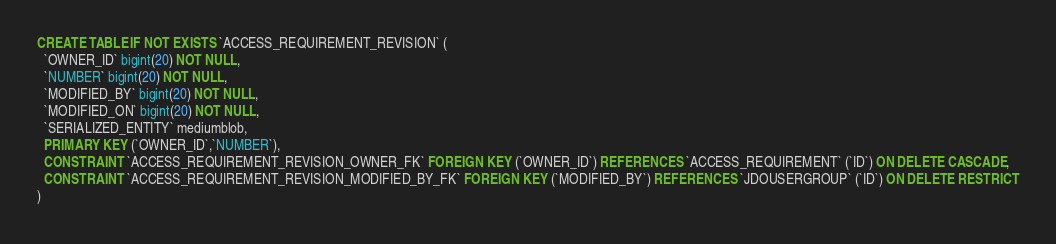Convert code to text. <code><loc_0><loc_0><loc_500><loc_500><_SQL_>CREATE TABLE IF NOT EXISTS `ACCESS_REQUIREMENT_REVISION` (
  `OWNER_ID` bigint(20) NOT NULL,
  `NUMBER` bigint(20) NOT NULL,
  `MODIFIED_BY` bigint(20) NOT NULL,
  `MODIFIED_ON` bigint(20) NOT NULL,
  `SERIALIZED_ENTITY` mediumblob,
  PRIMARY KEY (`OWNER_ID`,`NUMBER`),
  CONSTRAINT `ACCESS_REQUIREMENT_REVISION_OWNER_FK` FOREIGN KEY (`OWNER_ID`) REFERENCES `ACCESS_REQUIREMENT` (`ID`) ON DELETE CASCADE,
  CONSTRAINT `ACCESS_REQUIREMENT_REVISION_MODIFIED_BY_FK` FOREIGN KEY (`MODIFIED_BY`) REFERENCES `JDOUSERGROUP` (`ID`) ON DELETE RESTRICT
)
</code> 